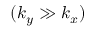<formula> <loc_0><loc_0><loc_500><loc_500>( k _ { y } \gg k _ { x } )</formula> 